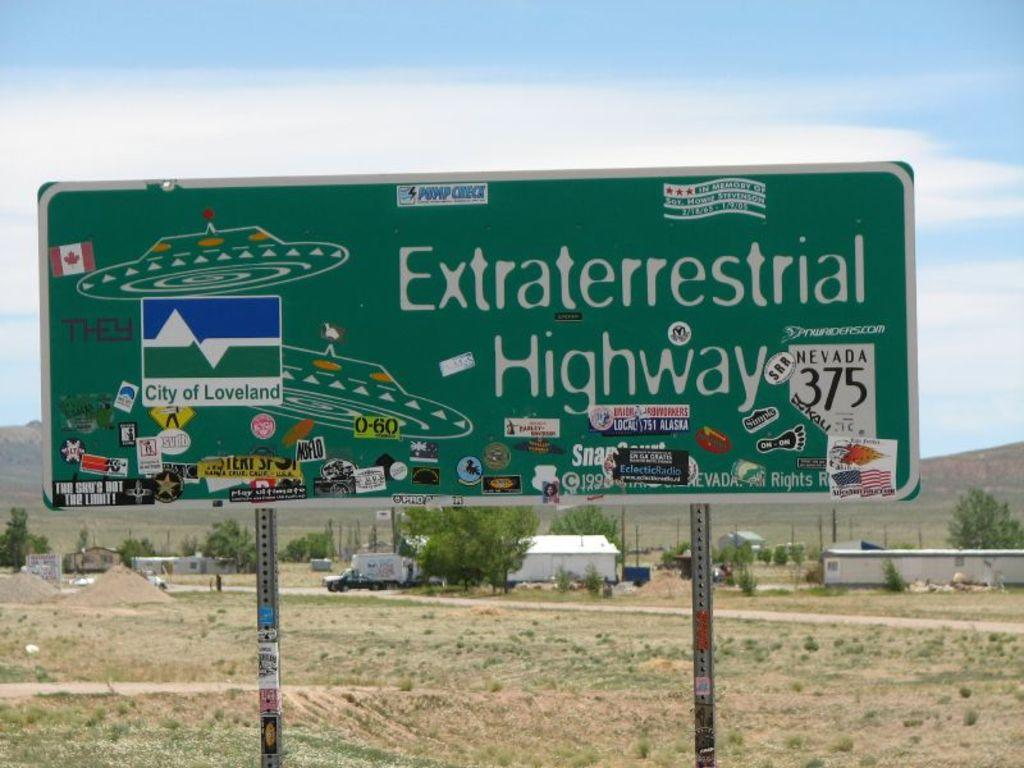<image>
Describe the image concisely. A green sign reading Extraterrestrial Highway next to drawings of flying saucers, plus many stickers stuck to it. 